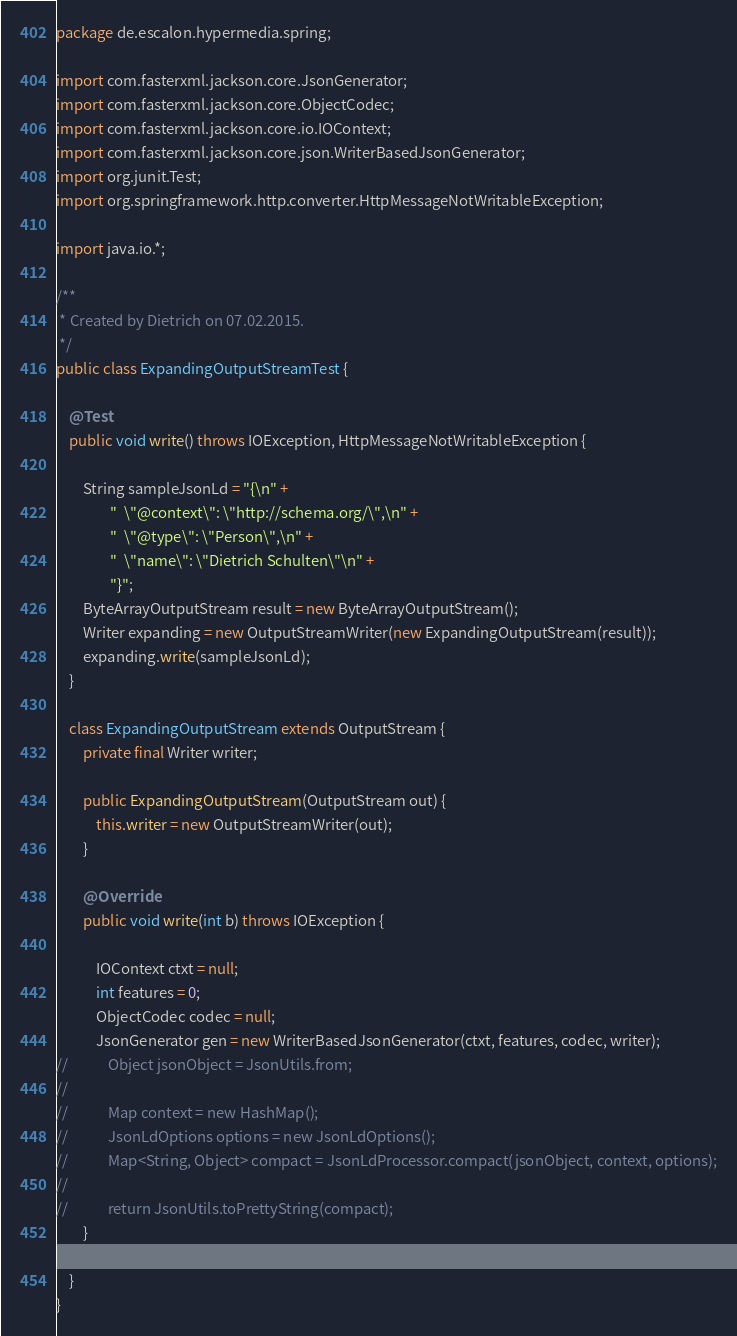Convert code to text. <code><loc_0><loc_0><loc_500><loc_500><_Java_>package de.escalon.hypermedia.spring;

import com.fasterxml.jackson.core.JsonGenerator;
import com.fasterxml.jackson.core.ObjectCodec;
import com.fasterxml.jackson.core.io.IOContext;
import com.fasterxml.jackson.core.json.WriterBasedJsonGenerator;
import org.junit.Test;
import org.springframework.http.converter.HttpMessageNotWritableException;

import java.io.*;

/**
 * Created by Dietrich on 07.02.2015.
 */
public class ExpandingOutputStreamTest {

    @Test
    public void write() throws IOException, HttpMessageNotWritableException {

        String sampleJsonLd = "{\n" +
                "  \"@context\": \"http://schema.org/\",\n" +
                "  \"@type\": \"Person\",\n" +
                "  \"name\": \"Dietrich Schulten\"\n" +
                "}";
        ByteArrayOutputStream result = new ByteArrayOutputStream();
        Writer expanding = new OutputStreamWriter(new ExpandingOutputStream(result));
        expanding.write(sampleJsonLd);
    }

    class ExpandingOutputStream extends OutputStream {
        private final Writer writer;

        public ExpandingOutputStream(OutputStream out) {
            this.writer = new OutputStreamWriter(out);
        }

        @Override
        public void write(int b) throws IOException {

            IOContext ctxt = null;
            int features = 0;
            ObjectCodec codec = null;
            JsonGenerator gen = new WriterBasedJsonGenerator(ctxt, features, codec, writer);
//            Object jsonObject = JsonUtils.from;
//
//            Map context = new HashMap();
//            JsonLdOptions options = new JsonLdOptions();
//            Map<String, Object> compact = JsonLdProcessor.compact(jsonObject, context, options);
//
//            return JsonUtils.toPrettyString(compact);
        }

    }
}

</code> 